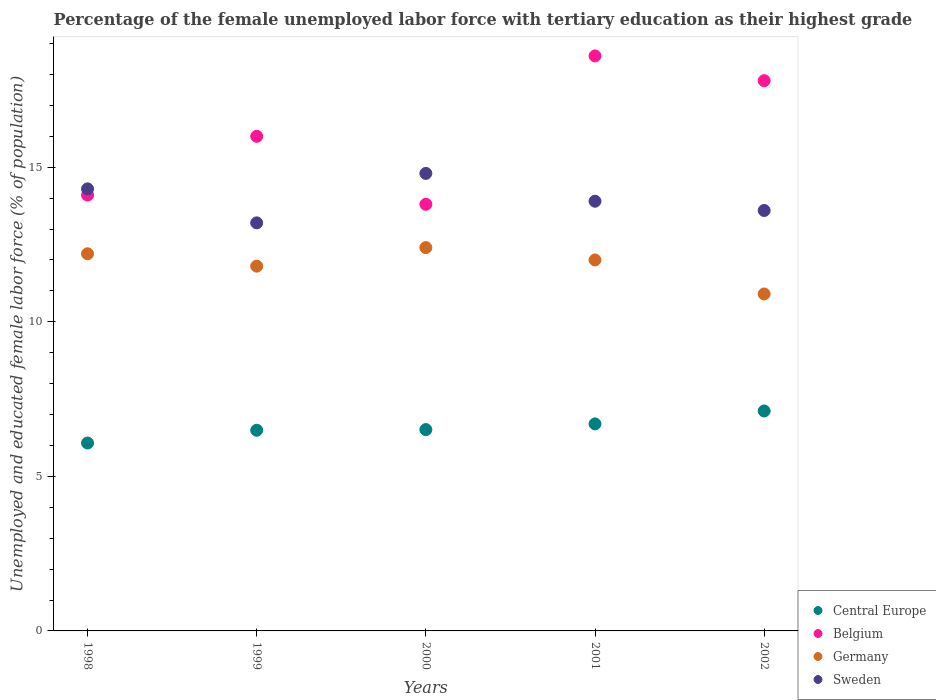How many different coloured dotlines are there?
Your response must be concise. 4. Across all years, what is the maximum percentage of the unemployed female labor force with tertiary education in Germany?
Give a very brief answer. 12.4. Across all years, what is the minimum percentage of the unemployed female labor force with tertiary education in Central Europe?
Your response must be concise. 6.08. What is the total percentage of the unemployed female labor force with tertiary education in Central Europe in the graph?
Ensure brevity in your answer.  32.89. What is the difference between the percentage of the unemployed female labor force with tertiary education in Sweden in 1998 and that in 2002?
Ensure brevity in your answer.  0.7. What is the difference between the percentage of the unemployed female labor force with tertiary education in Central Europe in 1999 and the percentage of the unemployed female labor force with tertiary education in Sweden in 2000?
Your answer should be compact. -8.31. What is the average percentage of the unemployed female labor force with tertiary education in Sweden per year?
Provide a succinct answer. 13.96. In the year 2001, what is the difference between the percentage of the unemployed female labor force with tertiary education in Belgium and percentage of the unemployed female labor force with tertiary education in Sweden?
Offer a very short reply. 4.7. In how many years, is the percentage of the unemployed female labor force with tertiary education in Sweden greater than 10 %?
Provide a succinct answer. 5. What is the ratio of the percentage of the unemployed female labor force with tertiary education in Sweden in 1998 to that in 2000?
Keep it short and to the point. 0.97. What is the difference between the highest and the second highest percentage of the unemployed female labor force with tertiary education in Germany?
Provide a succinct answer. 0.2. In how many years, is the percentage of the unemployed female labor force with tertiary education in Sweden greater than the average percentage of the unemployed female labor force with tertiary education in Sweden taken over all years?
Offer a terse response. 2. Is it the case that in every year, the sum of the percentage of the unemployed female labor force with tertiary education in Germany and percentage of the unemployed female labor force with tertiary education in Central Europe  is greater than the sum of percentage of the unemployed female labor force with tertiary education in Sweden and percentage of the unemployed female labor force with tertiary education in Belgium?
Keep it short and to the point. No. Is the percentage of the unemployed female labor force with tertiary education in Sweden strictly less than the percentage of the unemployed female labor force with tertiary education in Central Europe over the years?
Make the answer very short. No. How many dotlines are there?
Give a very brief answer. 4. How many years are there in the graph?
Make the answer very short. 5. What is the difference between two consecutive major ticks on the Y-axis?
Your answer should be compact. 5. Does the graph contain any zero values?
Your answer should be compact. No. Does the graph contain grids?
Your answer should be very brief. No. Where does the legend appear in the graph?
Provide a short and direct response. Bottom right. How are the legend labels stacked?
Your answer should be very brief. Vertical. What is the title of the graph?
Your response must be concise. Percentage of the female unemployed labor force with tertiary education as their highest grade. Does "Panama" appear as one of the legend labels in the graph?
Provide a succinct answer. No. What is the label or title of the X-axis?
Your answer should be very brief. Years. What is the label or title of the Y-axis?
Provide a succinct answer. Unemployed and educated female labor force (% of population). What is the Unemployed and educated female labor force (% of population) of Central Europe in 1998?
Keep it short and to the point. 6.08. What is the Unemployed and educated female labor force (% of population) of Belgium in 1998?
Offer a very short reply. 14.1. What is the Unemployed and educated female labor force (% of population) of Germany in 1998?
Provide a short and direct response. 12.2. What is the Unemployed and educated female labor force (% of population) of Sweden in 1998?
Keep it short and to the point. 14.3. What is the Unemployed and educated female labor force (% of population) of Central Europe in 1999?
Make the answer very short. 6.49. What is the Unemployed and educated female labor force (% of population) in Germany in 1999?
Provide a succinct answer. 11.8. What is the Unemployed and educated female labor force (% of population) in Sweden in 1999?
Offer a terse response. 13.2. What is the Unemployed and educated female labor force (% of population) in Central Europe in 2000?
Offer a very short reply. 6.51. What is the Unemployed and educated female labor force (% of population) in Belgium in 2000?
Your answer should be compact. 13.8. What is the Unemployed and educated female labor force (% of population) of Germany in 2000?
Make the answer very short. 12.4. What is the Unemployed and educated female labor force (% of population) in Sweden in 2000?
Keep it short and to the point. 14.8. What is the Unemployed and educated female labor force (% of population) in Central Europe in 2001?
Make the answer very short. 6.7. What is the Unemployed and educated female labor force (% of population) of Belgium in 2001?
Offer a terse response. 18.6. What is the Unemployed and educated female labor force (% of population) in Germany in 2001?
Provide a succinct answer. 12. What is the Unemployed and educated female labor force (% of population) of Sweden in 2001?
Your answer should be very brief. 13.9. What is the Unemployed and educated female labor force (% of population) of Central Europe in 2002?
Ensure brevity in your answer.  7.11. What is the Unemployed and educated female labor force (% of population) in Belgium in 2002?
Provide a succinct answer. 17.8. What is the Unemployed and educated female labor force (% of population) in Germany in 2002?
Your response must be concise. 10.9. What is the Unemployed and educated female labor force (% of population) in Sweden in 2002?
Provide a succinct answer. 13.6. Across all years, what is the maximum Unemployed and educated female labor force (% of population) of Central Europe?
Your answer should be very brief. 7.11. Across all years, what is the maximum Unemployed and educated female labor force (% of population) of Belgium?
Your answer should be very brief. 18.6. Across all years, what is the maximum Unemployed and educated female labor force (% of population) in Germany?
Your response must be concise. 12.4. Across all years, what is the maximum Unemployed and educated female labor force (% of population) in Sweden?
Your answer should be very brief. 14.8. Across all years, what is the minimum Unemployed and educated female labor force (% of population) of Central Europe?
Offer a terse response. 6.08. Across all years, what is the minimum Unemployed and educated female labor force (% of population) of Belgium?
Your response must be concise. 13.8. Across all years, what is the minimum Unemployed and educated female labor force (% of population) of Germany?
Keep it short and to the point. 10.9. Across all years, what is the minimum Unemployed and educated female labor force (% of population) in Sweden?
Offer a terse response. 13.2. What is the total Unemployed and educated female labor force (% of population) of Central Europe in the graph?
Make the answer very short. 32.89. What is the total Unemployed and educated female labor force (% of population) of Belgium in the graph?
Provide a succinct answer. 80.3. What is the total Unemployed and educated female labor force (% of population) of Germany in the graph?
Make the answer very short. 59.3. What is the total Unemployed and educated female labor force (% of population) in Sweden in the graph?
Ensure brevity in your answer.  69.8. What is the difference between the Unemployed and educated female labor force (% of population) of Central Europe in 1998 and that in 1999?
Make the answer very short. -0.41. What is the difference between the Unemployed and educated female labor force (% of population) in Central Europe in 1998 and that in 2000?
Provide a short and direct response. -0.43. What is the difference between the Unemployed and educated female labor force (% of population) in Belgium in 1998 and that in 2000?
Ensure brevity in your answer.  0.3. What is the difference between the Unemployed and educated female labor force (% of population) in Germany in 1998 and that in 2000?
Give a very brief answer. -0.2. What is the difference between the Unemployed and educated female labor force (% of population) in Sweden in 1998 and that in 2000?
Provide a succinct answer. -0.5. What is the difference between the Unemployed and educated female labor force (% of population) in Central Europe in 1998 and that in 2001?
Make the answer very short. -0.62. What is the difference between the Unemployed and educated female labor force (% of population) of Belgium in 1998 and that in 2001?
Provide a succinct answer. -4.5. What is the difference between the Unemployed and educated female labor force (% of population) in Germany in 1998 and that in 2001?
Provide a succinct answer. 0.2. What is the difference between the Unemployed and educated female labor force (% of population) in Sweden in 1998 and that in 2001?
Your response must be concise. 0.4. What is the difference between the Unemployed and educated female labor force (% of population) in Central Europe in 1998 and that in 2002?
Keep it short and to the point. -1.04. What is the difference between the Unemployed and educated female labor force (% of population) of Belgium in 1998 and that in 2002?
Your answer should be compact. -3.7. What is the difference between the Unemployed and educated female labor force (% of population) in Germany in 1998 and that in 2002?
Keep it short and to the point. 1.3. What is the difference between the Unemployed and educated female labor force (% of population) in Central Europe in 1999 and that in 2000?
Provide a short and direct response. -0.02. What is the difference between the Unemployed and educated female labor force (% of population) in Belgium in 1999 and that in 2000?
Offer a very short reply. 2.2. What is the difference between the Unemployed and educated female labor force (% of population) of Germany in 1999 and that in 2000?
Provide a succinct answer. -0.6. What is the difference between the Unemployed and educated female labor force (% of population) of Sweden in 1999 and that in 2000?
Make the answer very short. -1.6. What is the difference between the Unemployed and educated female labor force (% of population) in Central Europe in 1999 and that in 2001?
Your answer should be compact. -0.21. What is the difference between the Unemployed and educated female labor force (% of population) in Germany in 1999 and that in 2001?
Make the answer very short. -0.2. What is the difference between the Unemployed and educated female labor force (% of population) of Central Europe in 1999 and that in 2002?
Your answer should be very brief. -0.62. What is the difference between the Unemployed and educated female labor force (% of population) in Belgium in 1999 and that in 2002?
Provide a short and direct response. -1.8. What is the difference between the Unemployed and educated female labor force (% of population) in Germany in 1999 and that in 2002?
Ensure brevity in your answer.  0.9. What is the difference between the Unemployed and educated female labor force (% of population) of Sweden in 1999 and that in 2002?
Make the answer very short. -0.4. What is the difference between the Unemployed and educated female labor force (% of population) of Central Europe in 2000 and that in 2001?
Your answer should be very brief. -0.18. What is the difference between the Unemployed and educated female labor force (% of population) of Germany in 2000 and that in 2001?
Offer a very short reply. 0.4. What is the difference between the Unemployed and educated female labor force (% of population) of Central Europe in 2000 and that in 2002?
Your answer should be very brief. -0.6. What is the difference between the Unemployed and educated female labor force (% of population) in Belgium in 2000 and that in 2002?
Give a very brief answer. -4. What is the difference between the Unemployed and educated female labor force (% of population) of Sweden in 2000 and that in 2002?
Ensure brevity in your answer.  1.2. What is the difference between the Unemployed and educated female labor force (% of population) of Central Europe in 2001 and that in 2002?
Offer a terse response. -0.42. What is the difference between the Unemployed and educated female labor force (% of population) in Germany in 2001 and that in 2002?
Provide a succinct answer. 1.1. What is the difference between the Unemployed and educated female labor force (% of population) of Central Europe in 1998 and the Unemployed and educated female labor force (% of population) of Belgium in 1999?
Your answer should be very brief. -9.92. What is the difference between the Unemployed and educated female labor force (% of population) of Central Europe in 1998 and the Unemployed and educated female labor force (% of population) of Germany in 1999?
Offer a terse response. -5.72. What is the difference between the Unemployed and educated female labor force (% of population) of Central Europe in 1998 and the Unemployed and educated female labor force (% of population) of Sweden in 1999?
Make the answer very short. -7.12. What is the difference between the Unemployed and educated female labor force (% of population) in Belgium in 1998 and the Unemployed and educated female labor force (% of population) in Sweden in 1999?
Keep it short and to the point. 0.9. What is the difference between the Unemployed and educated female labor force (% of population) of Germany in 1998 and the Unemployed and educated female labor force (% of population) of Sweden in 1999?
Give a very brief answer. -1. What is the difference between the Unemployed and educated female labor force (% of population) in Central Europe in 1998 and the Unemployed and educated female labor force (% of population) in Belgium in 2000?
Provide a short and direct response. -7.72. What is the difference between the Unemployed and educated female labor force (% of population) of Central Europe in 1998 and the Unemployed and educated female labor force (% of population) of Germany in 2000?
Offer a terse response. -6.32. What is the difference between the Unemployed and educated female labor force (% of population) in Central Europe in 1998 and the Unemployed and educated female labor force (% of population) in Sweden in 2000?
Offer a very short reply. -8.72. What is the difference between the Unemployed and educated female labor force (% of population) in Belgium in 1998 and the Unemployed and educated female labor force (% of population) in Germany in 2000?
Your answer should be compact. 1.7. What is the difference between the Unemployed and educated female labor force (% of population) in Germany in 1998 and the Unemployed and educated female labor force (% of population) in Sweden in 2000?
Offer a terse response. -2.6. What is the difference between the Unemployed and educated female labor force (% of population) in Central Europe in 1998 and the Unemployed and educated female labor force (% of population) in Belgium in 2001?
Make the answer very short. -12.52. What is the difference between the Unemployed and educated female labor force (% of population) of Central Europe in 1998 and the Unemployed and educated female labor force (% of population) of Germany in 2001?
Keep it short and to the point. -5.92. What is the difference between the Unemployed and educated female labor force (% of population) in Central Europe in 1998 and the Unemployed and educated female labor force (% of population) in Sweden in 2001?
Offer a terse response. -7.82. What is the difference between the Unemployed and educated female labor force (% of population) in Belgium in 1998 and the Unemployed and educated female labor force (% of population) in Sweden in 2001?
Your answer should be compact. 0.2. What is the difference between the Unemployed and educated female labor force (% of population) of Germany in 1998 and the Unemployed and educated female labor force (% of population) of Sweden in 2001?
Provide a succinct answer. -1.7. What is the difference between the Unemployed and educated female labor force (% of population) of Central Europe in 1998 and the Unemployed and educated female labor force (% of population) of Belgium in 2002?
Keep it short and to the point. -11.72. What is the difference between the Unemployed and educated female labor force (% of population) of Central Europe in 1998 and the Unemployed and educated female labor force (% of population) of Germany in 2002?
Offer a very short reply. -4.82. What is the difference between the Unemployed and educated female labor force (% of population) in Central Europe in 1998 and the Unemployed and educated female labor force (% of population) in Sweden in 2002?
Ensure brevity in your answer.  -7.52. What is the difference between the Unemployed and educated female labor force (% of population) in Germany in 1998 and the Unemployed and educated female labor force (% of population) in Sweden in 2002?
Make the answer very short. -1.4. What is the difference between the Unemployed and educated female labor force (% of population) of Central Europe in 1999 and the Unemployed and educated female labor force (% of population) of Belgium in 2000?
Make the answer very short. -7.31. What is the difference between the Unemployed and educated female labor force (% of population) in Central Europe in 1999 and the Unemployed and educated female labor force (% of population) in Germany in 2000?
Ensure brevity in your answer.  -5.91. What is the difference between the Unemployed and educated female labor force (% of population) in Central Europe in 1999 and the Unemployed and educated female labor force (% of population) in Sweden in 2000?
Give a very brief answer. -8.31. What is the difference between the Unemployed and educated female labor force (% of population) of Germany in 1999 and the Unemployed and educated female labor force (% of population) of Sweden in 2000?
Make the answer very short. -3. What is the difference between the Unemployed and educated female labor force (% of population) of Central Europe in 1999 and the Unemployed and educated female labor force (% of population) of Belgium in 2001?
Ensure brevity in your answer.  -12.11. What is the difference between the Unemployed and educated female labor force (% of population) of Central Europe in 1999 and the Unemployed and educated female labor force (% of population) of Germany in 2001?
Make the answer very short. -5.51. What is the difference between the Unemployed and educated female labor force (% of population) of Central Europe in 1999 and the Unemployed and educated female labor force (% of population) of Sweden in 2001?
Offer a very short reply. -7.41. What is the difference between the Unemployed and educated female labor force (% of population) in Belgium in 1999 and the Unemployed and educated female labor force (% of population) in Germany in 2001?
Keep it short and to the point. 4. What is the difference between the Unemployed and educated female labor force (% of population) of Belgium in 1999 and the Unemployed and educated female labor force (% of population) of Sweden in 2001?
Your answer should be very brief. 2.1. What is the difference between the Unemployed and educated female labor force (% of population) of Central Europe in 1999 and the Unemployed and educated female labor force (% of population) of Belgium in 2002?
Offer a terse response. -11.31. What is the difference between the Unemployed and educated female labor force (% of population) in Central Europe in 1999 and the Unemployed and educated female labor force (% of population) in Germany in 2002?
Your answer should be compact. -4.41. What is the difference between the Unemployed and educated female labor force (% of population) of Central Europe in 1999 and the Unemployed and educated female labor force (% of population) of Sweden in 2002?
Ensure brevity in your answer.  -7.11. What is the difference between the Unemployed and educated female labor force (% of population) of Belgium in 1999 and the Unemployed and educated female labor force (% of population) of Germany in 2002?
Ensure brevity in your answer.  5.1. What is the difference between the Unemployed and educated female labor force (% of population) of Central Europe in 2000 and the Unemployed and educated female labor force (% of population) of Belgium in 2001?
Offer a terse response. -12.09. What is the difference between the Unemployed and educated female labor force (% of population) in Central Europe in 2000 and the Unemployed and educated female labor force (% of population) in Germany in 2001?
Make the answer very short. -5.49. What is the difference between the Unemployed and educated female labor force (% of population) in Central Europe in 2000 and the Unemployed and educated female labor force (% of population) in Sweden in 2001?
Your answer should be compact. -7.39. What is the difference between the Unemployed and educated female labor force (% of population) in Belgium in 2000 and the Unemployed and educated female labor force (% of population) in Germany in 2001?
Your response must be concise. 1.8. What is the difference between the Unemployed and educated female labor force (% of population) of Central Europe in 2000 and the Unemployed and educated female labor force (% of population) of Belgium in 2002?
Provide a short and direct response. -11.29. What is the difference between the Unemployed and educated female labor force (% of population) of Central Europe in 2000 and the Unemployed and educated female labor force (% of population) of Germany in 2002?
Make the answer very short. -4.39. What is the difference between the Unemployed and educated female labor force (% of population) of Central Europe in 2000 and the Unemployed and educated female labor force (% of population) of Sweden in 2002?
Your answer should be very brief. -7.09. What is the difference between the Unemployed and educated female labor force (% of population) in Belgium in 2000 and the Unemployed and educated female labor force (% of population) in Sweden in 2002?
Offer a very short reply. 0.2. What is the difference between the Unemployed and educated female labor force (% of population) of Germany in 2000 and the Unemployed and educated female labor force (% of population) of Sweden in 2002?
Ensure brevity in your answer.  -1.2. What is the difference between the Unemployed and educated female labor force (% of population) in Central Europe in 2001 and the Unemployed and educated female labor force (% of population) in Belgium in 2002?
Your response must be concise. -11.1. What is the difference between the Unemployed and educated female labor force (% of population) in Central Europe in 2001 and the Unemployed and educated female labor force (% of population) in Germany in 2002?
Provide a succinct answer. -4.2. What is the difference between the Unemployed and educated female labor force (% of population) of Central Europe in 2001 and the Unemployed and educated female labor force (% of population) of Sweden in 2002?
Your answer should be compact. -6.9. What is the difference between the Unemployed and educated female labor force (% of population) of Belgium in 2001 and the Unemployed and educated female labor force (% of population) of Germany in 2002?
Provide a succinct answer. 7.7. What is the average Unemployed and educated female labor force (% of population) of Central Europe per year?
Keep it short and to the point. 6.58. What is the average Unemployed and educated female labor force (% of population) in Belgium per year?
Your answer should be compact. 16.06. What is the average Unemployed and educated female labor force (% of population) in Germany per year?
Offer a very short reply. 11.86. What is the average Unemployed and educated female labor force (% of population) of Sweden per year?
Provide a short and direct response. 13.96. In the year 1998, what is the difference between the Unemployed and educated female labor force (% of population) of Central Europe and Unemployed and educated female labor force (% of population) of Belgium?
Make the answer very short. -8.02. In the year 1998, what is the difference between the Unemployed and educated female labor force (% of population) in Central Europe and Unemployed and educated female labor force (% of population) in Germany?
Offer a terse response. -6.12. In the year 1998, what is the difference between the Unemployed and educated female labor force (% of population) in Central Europe and Unemployed and educated female labor force (% of population) in Sweden?
Your answer should be very brief. -8.22. In the year 1999, what is the difference between the Unemployed and educated female labor force (% of population) in Central Europe and Unemployed and educated female labor force (% of population) in Belgium?
Keep it short and to the point. -9.51. In the year 1999, what is the difference between the Unemployed and educated female labor force (% of population) in Central Europe and Unemployed and educated female labor force (% of population) in Germany?
Make the answer very short. -5.31. In the year 1999, what is the difference between the Unemployed and educated female labor force (% of population) of Central Europe and Unemployed and educated female labor force (% of population) of Sweden?
Give a very brief answer. -6.71. In the year 1999, what is the difference between the Unemployed and educated female labor force (% of population) of Belgium and Unemployed and educated female labor force (% of population) of Germany?
Ensure brevity in your answer.  4.2. In the year 1999, what is the difference between the Unemployed and educated female labor force (% of population) in Belgium and Unemployed and educated female labor force (% of population) in Sweden?
Your response must be concise. 2.8. In the year 2000, what is the difference between the Unemployed and educated female labor force (% of population) in Central Europe and Unemployed and educated female labor force (% of population) in Belgium?
Ensure brevity in your answer.  -7.29. In the year 2000, what is the difference between the Unemployed and educated female labor force (% of population) of Central Europe and Unemployed and educated female labor force (% of population) of Germany?
Ensure brevity in your answer.  -5.89. In the year 2000, what is the difference between the Unemployed and educated female labor force (% of population) of Central Europe and Unemployed and educated female labor force (% of population) of Sweden?
Provide a short and direct response. -8.29. In the year 2000, what is the difference between the Unemployed and educated female labor force (% of population) of Belgium and Unemployed and educated female labor force (% of population) of Germany?
Offer a very short reply. 1.4. In the year 2000, what is the difference between the Unemployed and educated female labor force (% of population) in Belgium and Unemployed and educated female labor force (% of population) in Sweden?
Your answer should be very brief. -1. In the year 2001, what is the difference between the Unemployed and educated female labor force (% of population) in Central Europe and Unemployed and educated female labor force (% of population) in Belgium?
Your answer should be very brief. -11.9. In the year 2001, what is the difference between the Unemployed and educated female labor force (% of population) in Central Europe and Unemployed and educated female labor force (% of population) in Germany?
Make the answer very short. -5.3. In the year 2001, what is the difference between the Unemployed and educated female labor force (% of population) of Central Europe and Unemployed and educated female labor force (% of population) of Sweden?
Ensure brevity in your answer.  -7.2. In the year 2001, what is the difference between the Unemployed and educated female labor force (% of population) of Belgium and Unemployed and educated female labor force (% of population) of Sweden?
Give a very brief answer. 4.7. In the year 2001, what is the difference between the Unemployed and educated female labor force (% of population) of Germany and Unemployed and educated female labor force (% of population) of Sweden?
Provide a short and direct response. -1.9. In the year 2002, what is the difference between the Unemployed and educated female labor force (% of population) in Central Europe and Unemployed and educated female labor force (% of population) in Belgium?
Your response must be concise. -10.69. In the year 2002, what is the difference between the Unemployed and educated female labor force (% of population) of Central Europe and Unemployed and educated female labor force (% of population) of Germany?
Give a very brief answer. -3.79. In the year 2002, what is the difference between the Unemployed and educated female labor force (% of population) in Central Europe and Unemployed and educated female labor force (% of population) in Sweden?
Provide a succinct answer. -6.49. In the year 2002, what is the difference between the Unemployed and educated female labor force (% of population) in Belgium and Unemployed and educated female labor force (% of population) in Sweden?
Provide a succinct answer. 4.2. What is the ratio of the Unemployed and educated female labor force (% of population) in Central Europe in 1998 to that in 1999?
Offer a terse response. 0.94. What is the ratio of the Unemployed and educated female labor force (% of population) of Belgium in 1998 to that in 1999?
Offer a very short reply. 0.88. What is the ratio of the Unemployed and educated female labor force (% of population) of Germany in 1998 to that in 1999?
Provide a short and direct response. 1.03. What is the ratio of the Unemployed and educated female labor force (% of population) in Central Europe in 1998 to that in 2000?
Your response must be concise. 0.93. What is the ratio of the Unemployed and educated female labor force (% of population) in Belgium in 1998 to that in 2000?
Give a very brief answer. 1.02. What is the ratio of the Unemployed and educated female labor force (% of population) of Germany in 1998 to that in 2000?
Provide a succinct answer. 0.98. What is the ratio of the Unemployed and educated female labor force (% of population) of Sweden in 1998 to that in 2000?
Give a very brief answer. 0.97. What is the ratio of the Unemployed and educated female labor force (% of population) of Central Europe in 1998 to that in 2001?
Ensure brevity in your answer.  0.91. What is the ratio of the Unemployed and educated female labor force (% of population) in Belgium in 1998 to that in 2001?
Make the answer very short. 0.76. What is the ratio of the Unemployed and educated female labor force (% of population) of Germany in 1998 to that in 2001?
Your answer should be very brief. 1.02. What is the ratio of the Unemployed and educated female labor force (% of population) of Sweden in 1998 to that in 2001?
Offer a very short reply. 1.03. What is the ratio of the Unemployed and educated female labor force (% of population) in Central Europe in 1998 to that in 2002?
Offer a very short reply. 0.85. What is the ratio of the Unemployed and educated female labor force (% of population) in Belgium in 1998 to that in 2002?
Keep it short and to the point. 0.79. What is the ratio of the Unemployed and educated female labor force (% of population) of Germany in 1998 to that in 2002?
Keep it short and to the point. 1.12. What is the ratio of the Unemployed and educated female labor force (% of population) of Sweden in 1998 to that in 2002?
Give a very brief answer. 1.05. What is the ratio of the Unemployed and educated female labor force (% of population) of Central Europe in 1999 to that in 2000?
Your answer should be very brief. 1. What is the ratio of the Unemployed and educated female labor force (% of population) in Belgium in 1999 to that in 2000?
Your answer should be compact. 1.16. What is the ratio of the Unemployed and educated female labor force (% of population) in Germany in 1999 to that in 2000?
Provide a short and direct response. 0.95. What is the ratio of the Unemployed and educated female labor force (% of population) of Sweden in 1999 to that in 2000?
Ensure brevity in your answer.  0.89. What is the ratio of the Unemployed and educated female labor force (% of population) of Central Europe in 1999 to that in 2001?
Your answer should be compact. 0.97. What is the ratio of the Unemployed and educated female labor force (% of population) of Belgium in 1999 to that in 2001?
Your response must be concise. 0.86. What is the ratio of the Unemployed and educated female labor force (% of population) in Germany in 1999 to that in 2001?
Ensure brevity in your answer.  0.98. What is the ratio of the Unemployed and educated female labor force (% of population) of Sweden in 1999 to that in 2001?
Offer a very short reply. 0.95. What is the ratio of the Unemployed and educated female labor force (% of population) in Central Europe in 1999 to that in 2002?
Offer a terse response. 0.91. What is the ratio of the Unemployed and educated female labor force (% of population) in Belgium in 1999 to that in 2002?
Your answer should be compact. 0.9. What is the ratio of the Unemployed and educated female labor force (% of population) in Germany in 1999 to that in 2002?
Your answer should be very brief. 1.08. What is the ratio of the Unemployed and educated female labor force (% of population) in Sweden in 1999 to that in 2002?
Your answer should be compact. 0.97. What is the ratio of the Unemployed and educated female labor force (% of population) of Central Europe in 2000 to that in 2001?
Your answer should be very brief. 0.97. What is the ratio of the Unemployed and educated female labor force (% of population) in Belgium in 2000 to that in 2001?
Your answer should be very brief. 0.74. What is the ratio of the Unemployed and educated female labor force (% of population) of Sweden in 2000 to that in 2001?
Provide a short and direct response. 1.06. What is the ratio of the Unemployed and educated female labor force (% of population) of Central Europe in 2000 to that in 2002?
Your answer should be very brief. 0.92. What is the ratio of the Unemployed and educated female labor force (% of population) of Belgium in 2000 to that in 2002?
Make the answer very short. 0.78. What is the ratio of the Unemployed and educated female labor force (% of population) in Germany in 2000 to that in 2002?
Make the answer very short. 1.14. What is the ratio of the Unemployed and educated female labor force (% of population) in Sweden in 2000 to that in 2002?
Your answer should be very brief. 1.09. What is the ratio of the Unemployed and educated female labor force (% of population) in Central Europe in 2001 to that in 2002?
Keep it short and to the point. 0.94. What is the ratio of the Unemployed and educated female labor force (% of population) in Belgium in 2001 to that in 2002?
Offer a very short reply. 1.04. What is the ratio of the Unemployed and educated female labor force (% of population) of Germany in 2001 to that in 2002?
Provide a succinct answer. 1.1. What is the ratio of the Unemployed and educated female labor force (% of population) in Sweden in 2001 to that in 2002?
Ensure brevity in your answer.  1.02. What is the difference between the highest and the second highest Unemployed and educated female labor force (% of population) of Central Europe?
Give a very brief answer. 0.42. What is the difference between the highest and the second highest Unemployed and educated female labor force (% of population) of Germany?
Provide a short and direct response. 0.2. What is the difference between the highest and the second highest Unemployed and educated female labor force (% of population) of Sweden?
Keep it short and to the point. 0.5. What is the difference between the highest and the lowest Unemployed and educated female labor force (% of population) of Central Europe?
Make the answer very short. 1.04. What is the difference between the highest and the lowest Unemployed and educated female labor force (% of population) in Belgium?
Ensure brevity in your answer.  4.8. What is the difference between the highest and the lowest Unemployed and educated female labor force (% of population) of Sweden?
Ensure brevity in your answer.  1.6. 